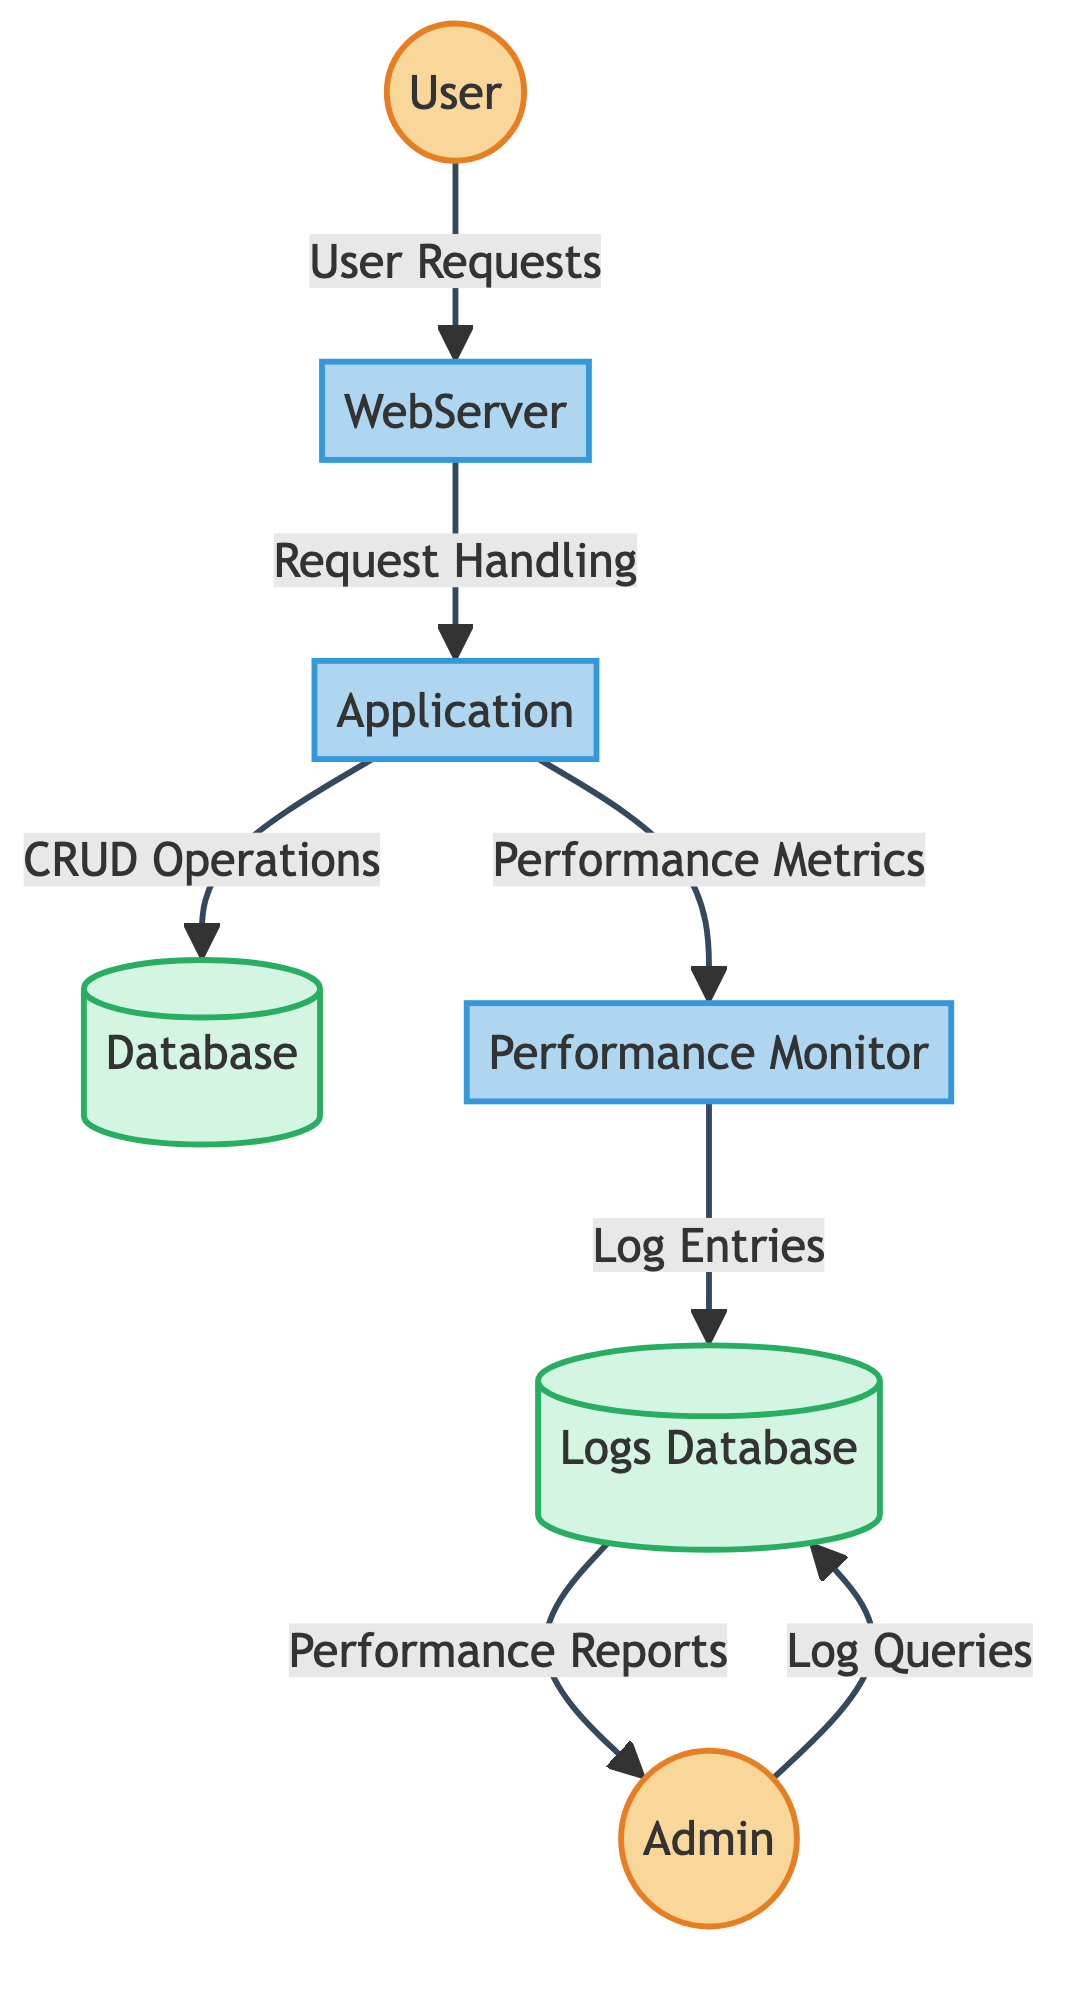What is the type of the "WebServer"? "WebServer" is classified as a process in the diagram, indicating its role in handling requests between the user and the application.
Answer: process How many external entities are represented in the diagram? The diagram shows two external entities: "User" and "Admin". Counting these yields a total of two external entities.
Answer: 2 What data flows from the "Application" to the "Database"? The flow from "Application" to "Database" is labeled "CRUDOperations", indicating the operations performed on the database by the application.
Answer: CRUDOperations Which process logs performance metrics? The "PerformanceMonitor" process is responsible for monitoring and logging performance metrics as shown by its data flow to the "LogsDatabase".
Answer: PerformanceMonitor What type of data store is "LogsDatabase"? "LogsDatabase" is identified as a data store, which is used to store performance logs and metrics for subsequent analysis.
Answer: data store What is the relationship between "PerformanceMonitor" and "LogsDatabase"? The relationship indicates that "PerformanceMonitor" sends "LogEntries" to "LogsDatabase", which stores these entries for future reference.
Answer: LogEntries What data does "Admin" retrieve from "LogsDatabase"? "Admin" retrieves "PerformanceReports" from the "LogsDatabase", which allows analysis of the performance logs generated by the application.
Answer: PerformanceReports Which external entity initiates requests to the "WebServer"? The external entity that initiates requests is the "User", as shown by the directed flow of "UserRequests" to the "WebServer".
Answer: User What process handles incoming user requests? The "WebServer" process is designated to handle incoming user requests and delegate them to the application for further processing.
Answer: WebServer 